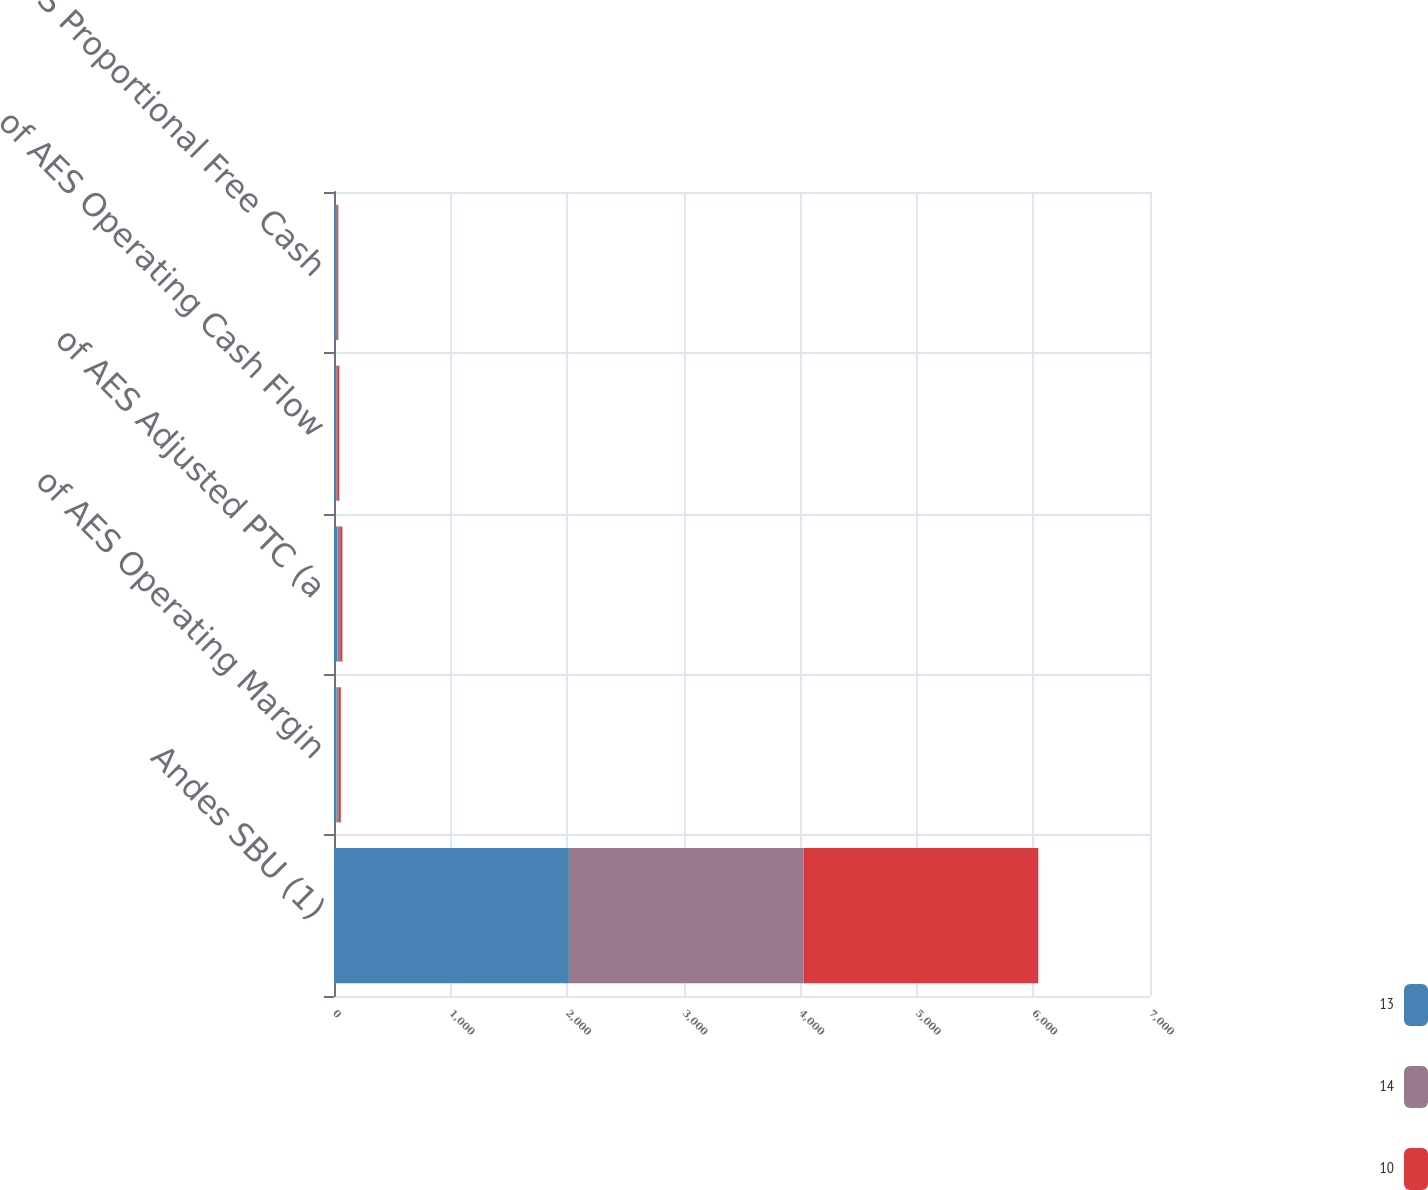Convert chart to OTSL. <chart><loc_0><loc_0><loc_500><loc_500><stacked_bar_chart><ecel><fcel>Andes SBU (1)<fcel>of AES Operating Margin<fcel>of AES Adjusted PTC (a<fcel>of AES Operating Cash Flow<fcel>of AES Proportional Free Cash<nl><fcel>13<fcel>2015<fcel>22<fcel>30<fcel>18<fcel>14<nl><fcel>14<fcel>2014<fcel>19<fcel>23<fcel>16<fcel>13<nl><fcel>10<fcel>2013<fcel>17<fcel>19<fcel>11<fcel>10<nl></chart> 